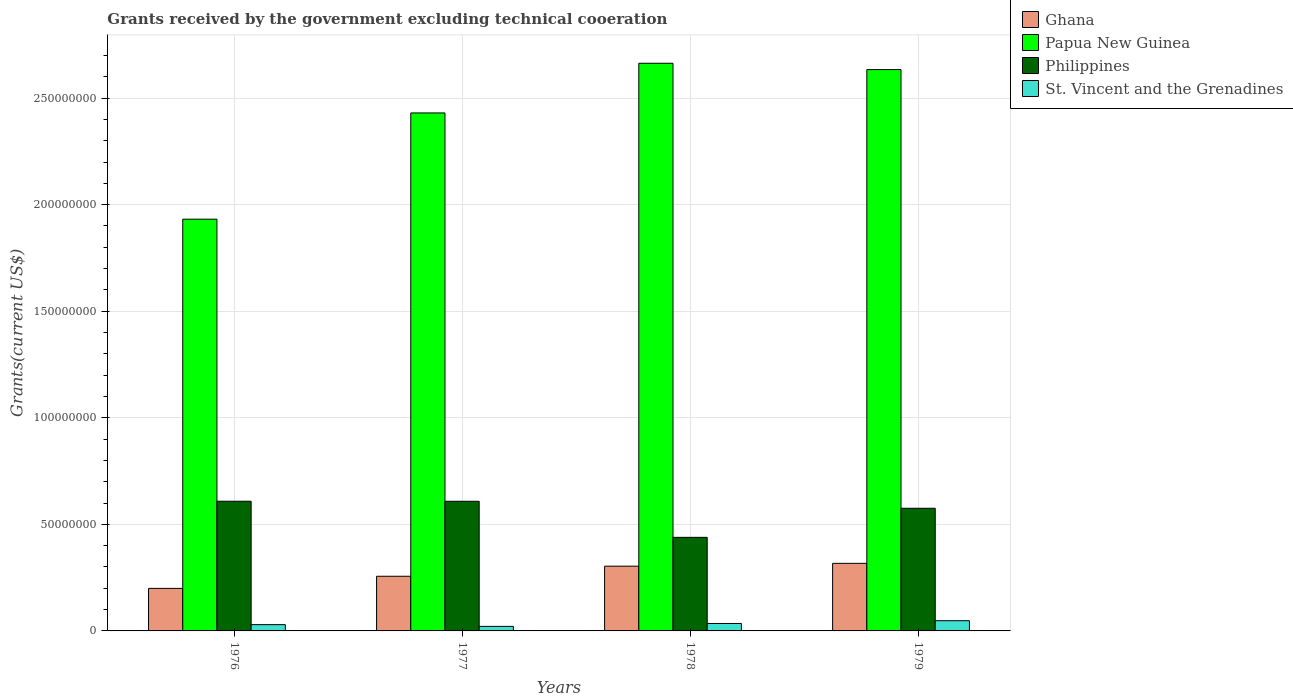Are the number of bars on each tick of the X-axis equal?
Your response must be concise. Yes. How many bars are there on the 4th tick from the right?
Offer a very short reply. 4. In how many cases, is the number of bars for a given year not equal to the number of legend labels?
Provide a short and direct response. 0. What is the total grants received by the government in Philippines in 1977?
Offer a very short reply. 6.08e+07. Across all years, what is the maximum total grants received by the government in Philippines?
Provide a short and direct response. 6.08e+07. Across all years, what is the minimum total grants received by the government in St. Vincent and the Grenadines?
Keep it short and to the point. 2.13e+06. In which year was the total grants received by the government in Papua New Guinea maximum?
Your response must be concise. 1978. In which year was the total grants received by the government in Papua New Guinea minimum?
Make the answer very short. 1976. What is the total total grants received by the government in Philippines in the graph?
Your answer should be compact. 2.23e+08. What is the difference between the total grants received by the government in Philippines in 1977 and that in 1979?
Your response must be concise. 3.29e+06. What is the difference between the total grants received by the government in Papua New Guinea in 1976 and the total grants received by the government in Ghana in 1978?
Offer a terse response. 1.63e+08. What is the average total grants received by the government in Philippines per year?
Ensure brevity in your answer.  5.58e+07. In the year 1976, what is the difference between the total grants received by the government in Papua New Guinea and total grants received by the government in Philippines?
Give a very brief answer. 1.32e+08. What is the ratio of the total grants received by the government in Ghana in 1977 to that in 1978?
Your answer should be very brief. 0.84. Is the total grants received by the government in Philippines in 1978 less than that in 1979?
Your response must be concise. Yes. Is the difference between the total grants received by the government in Papua New Guinea in 1976 and 1977 greater than the difference between the total grants received by the government in Philippines in 1976 and 1977?
Offer a terse response. No. What is the difference between the highest and the second highest total grants received by the government in St. Vincent and the Grenadines?
Ensure brevity in your answer.  1.30e+06. What is the difference between the highest and the lowest total grants received by the government in Papua New Guinea?
Your answer should be very brief. 7.32e+07. In how many years, is the total grants received by the government in Papua New Guinea greater than the average total grants received by the government in Papua New Guinea taken over all years?
Keep it short and to the point. 3. Is the sum of the total grants received by the government in St. Vincent and the Grenadines in 1977 and 1979 greater than the maximum total grants received by the government in Papua New Guinea across all years?
Provide a short and direct response. No. Is it the case that in every year, the sum of the total grants received by the government in Philippines and total grants received by the government in St. Vincent and the Grenadines is greater than the sum of total grants received by the government in Ghana and total grants received by the government in Papua New Guinea?
Your answer should be compact. No. What does the 2nd bar from the left in 1978 represents?
Your response must be concise. Papua New Guinea. What does the 2nd bar from the right in 1978 represents?
Offer a very short reply. Philippines. How many bars are there?
Offer a terse response. 16. How many years are there in the graph?
Make the answer very short. 4. Does the graph contain any zero values?
Your answer should be compact. No. Does the graph contain grids?
Provide a short and direct response. Yes. Where does the legend appear in the graph?
Ensure brevity in your answer.  Top right. How many legend labels are there?
Offer a terse response. 4. What is the title of the graph?
Offer a very short reply. Grants received by the government excluding technical cooeration. Does "Ghana" appear as one of the legend labels in the graph?
Offer a terse response. Yes. What is the label or title of the Y-axis?
Provide a succinct answer. Grants(current US$). What is the Grants(current US$) of Ghana in 1976?
Provide a succinct answer. 2.00e+07. What is the Grants(current US$) in Papua New Guinea in 1976?
Offer a terse response. 1.93e+08. What is the Grants(current US$) in Philippines in 1976?
Keep it short and to the point. 6.08e+07. What is the Grants(current US$) of St. Vincent and the Grenadines in 1976?
Ensure brevity in your answer.  2.94e+06. What is the Grants(current US$) in Ghana in 1977?
Provide a succinct answer. 2.56e+07. What is the Grants(current US$) of Papua New Guinea in 1977?
Provide a short and direct response. 2.43e+08. What is the Grants(current US$) of Philippines in 1977?
Make the answer very short. 6.08e+07. What is the Grants(current US$) of St. Vincent and the Grenadines in 1977?
Provide a short and direct response. 2.13e+06. What is the Grants(current US$) of Ghana in 1978?
Provide a short and direct response. 3.04e+07. What is the Grants(current US$) of Papua New Guinea in 1978?
Your response must be concise. 2.66e+08. What is the Grants(current US$) of Philippines in 1978?
Provide a succinct answer. 4.39e+07. What is the Grants(current US$) in St. Vincent and the Grenadines in 1978?
Make the answer very short. 3.49e+06. What is the Grants(current US$) of Ghana in 1979?
Your answer should be compact. 3.17e+07. What is the Grants(current US$) in Papua New Guinea in 1979?
Your response must be concise. 2.63e+08. What is the Grants(current US$) of Philippines in 1979?
Your response must be concise. 5.75e+07. What is the Grants(current US$) of St. Vincent and the Grenadines in 1979?
Ensure brevity in your answer.  4.79e+06. Across all years, what is the maximum Grants(current US$) in Ghana?
Give a very brief answer. 3.17e+07. Across all years, what is the maximum Grants(current US$) in Papua New Guinea?
Provide a short and direct response. 2.66e+08. Across all years, what is the maximum Grants(current US$) of Philippines?
Make the answer very short. 6.08e+07. Across all years, what is the maximum Grants(current US$) in St. Vincent and the Grenadines?
Provide a succinct answer. 4.79e+06. Across all years, what is the minimum Grants(current US$) of Ghana?
Offer a terse response. 2.00e+07. Across all years, what is the minimum Grants(current US$) of Papua New Guinea?
Make the answer very short. 1.93e+08. Across all years, what is the minimum Grants(current US$) in Philippines?
Your answer should be very brief. 4.39e+07. Across all years, what is the minimum Grants(current US$) of St. Vincent and the Grenadines?
Keep it short and to the point. 2.13e+06. What is the total Grants(current US$) of Ghana in the graph?
Your answer should be very brief. 1.08e+08. What is the total Grants(current US$) in Papua New Guinea in the graph?
Your response must be concise. 9.66e+08. What is the total Grants(current US$) in Philippines in the graph?
Ensure brevity in your answer.  2.23e+08. What is the total Grants(current US$) in St. Vincent and the Grenadines in the graph?
Your answer should be compact. 1.34e+07. What is the difference between the Grants(current US$) in Ghana in 1976 and that in 1977?
Make the answer very short. -5.69e+06. What is the difference between the Grants(current US$) of Papua New Guinea in 1976 and that in 1977?
Provide a succinct answer. -4.98e+07. What is the difference between the Grants(current US$) of Philippines in 1976 and that in 1977?
Your response must be concise. 10000. What is the difference between the Grants(current US$) in St. Vincent and the Grenadines in 1976 and that in 1977?
Keep it short and to the point. 8.10e+05. What is the difference between the Grants(current US$) of Ghana in 1976 and that in 1978?
Make the answer very short. -1.04e+07. What is the difference between the Grants(current US$) of Papua New Guinea in 1976 and that in 1978?
Offer a terse response. -7.32e+07. What is the difference between the Grants(current US$) in Philippines in 1976 and that in 1978?
Provide a succinct answer. 1.69e+07. What is the difference between the Grants(current US$) of St. Vincent and the Grenadines in 1976 and that in 1978?
Make the answer very short. -5.50e+05. What is the difference between the Grants(current US$) of Ghana in 1976 and that in 1979?
Make the answer very short. -1.17e+07. What is the difference between the Grants(current US$) in Papua New Guinea in 1976 and that in 1979?
Make the answer very short. -7.02e+07. What is the difference between the Grants(current US$) in Philippines in 1976 and that in 1979?
Your answer should be very brief. 3.30e+06. What is the difference between the Grants(current US$) in St. Vincent and the Grenadines in 1976 and that in 1979?
Give a very brief answer. -1.85e+06. What is the difference between the Grants(current US$) of Ghana in 1977 and that in 1978?
Your answer should be compact. -4.73e+06. What is the difference between the Grants(current US$) in Papua New Guinea in 1977 and that in 1978?
Provide a short and direct response. -2.33e+07. What is the difference between the Grants(current US$) in Philippines in 1977 and that in 1978?
Offer a terse response. 1.69e+07. What is the difference between the Grants(current US$) of St. Vincent and the Grenadines in 1977 and that in 1978?
Offer a terse response. -1.36e+06. What is the difference between the Grants(current US$) of Ghana in 1977 and that in 1979?
Give a very brief answer. -6.05e+06. What is the difference between the Grants(current US$) of Papua New Guinea in 1977 and that in 1979?
Offer a terse response. -2.04e+07. What is the difference between the Grants(current US$) in Philippines in 1977 and that in 1979?
Your answer should be very brief. 3.29e+06. What is the difference between the Grants(current US$) of St. Vincent and the Grenadines in 1977 and that in 1979?
Ensure brevity in your answer.  -2.66e+06. What is the difference between the Grants(current US$) of Ghana in 1978 and that in 1979?
Your answer should be very brief. -1.32e+06. What is the difference between the Grants(current US$) in Papua New Guinea in 1978 and that in 1979?
Your answer should be compact. 2.96e+06. What is the difference between the Grants(current US$) in Philippines in 1978 and that in 1979?
Provide a short and direct response. -1.36e+07. What is the difference between the Grants(current US$) of St. Vincent and the Grenadines in 1978 and that in 1979?
Ensure brevity in your answer.  -1.30e+06. What is the difference between the Grants(current US$) of Ghana in 1976 and the Grants(current US$) of Papua New Guinea in 1977?
Keep it short and to the point. -2.23e+08. What is the difference between the Grants(current US$) of Ghana in 1976 and the Grants(current US$) of Philippines in 1977?
Your response must be concise. -4.09e+07. What is the difference between the Grants(current US$) in Ghana in 1976 and the Grants(current US$) in St. Vincent and the Grenadines in 1977?
Keep it short and to the point. 1.78e+07. What is the difference between the Grants(current US$) in Papua New Guinea in 1976 and the Grants(current US$) in Philippines in 1977?
Make the answer very short. 1.32e+08. What is the difference between the Grants(current US$) in Papua New Guinea in 1976 and the Grants(current US$) in St. Vincent and the Grenadines in 1977?
Make the answer very short. 1.91e+08. What is the difference between the Grants(current US$) in Philippines in 1976 and the Grants(current US$) in St. Vincent and the Grenadines in 1977?
Provide a succinct answer. 5.87e+07. What is the difference between the Grants(current US$) of Ghana in 1976 and the Grants(current US$) of Papua New Guinea in 1978?
Give a very brief answer. -2.46e+08. What is the difference between the Grants(current US$) in Ghana in 1976 and the Grants(current US$) in Philippines in 1978?
Your answer should be compact. -2.39e+07. What is the difference between the Grants(current US$) in Ghana in 1976 and the Grants(current US$) in St. Vincent and the Grenadines in 1978?
Give a very brief answer. 1.65e+07. What is the difference between the Grants(current US$) in Papua New Guinea in 1976 and the Grants(current US$) in Philippines in 1978?
Offer a terse response. 1.49e+08. What is the difference between the Grants(current US$) in Papua New Guinea in 1976 and the Grants(current US$) in St. Vincent and the Grenadines in 1978?
Ensure brevity in your answer.  1.90e+08. What is the difference between the Grants(current US$) of Philippines in 1976 and the Grants(current US$) of St. Vincent and the Grenadines in 1978?
Provide a short and direct response. 5.74e+07. What is the difference between the Grants(current US$) in Ghana in 1976 and the Grants(current US$) in Papua New Guinea in 1979?
Give a very brief answer. -2.43e+08. What is the difference between the Grants(current US$) in Ghana in 1976 and the Grants(current US$) in Philippines in 1979?
Ensure brevity in your answer.  -3.76e+07. What is the difference between the Grants(current US$) in Ghana in 1976 and the Grants(current US$) in St. Vincent and the Grenadines in 1979?
Your response must be concise. 1.52e+07. What is the difference between the Grants(current US$) in Papua New Guinea in 1976 and the Grants(current US$) in Philippines in 1979?
Provide a succinct answer. 1.36e+08. What is the difference between the Grants(current US$) in Papua New Guinea in 1976 and the Grants(current US$) in St. Vincent and the Grenadines in 1979?
Your response must be concise. 1.88e+08. What is the difference between the Grants(current US$) of Philippines in 1976 and the Grants(current US$) of St. Vincent and the Grenadines in 1979?
Offer a very short reply. 5.60e+07. What is the difference between the Grants(current US$) in Ghana in 1977 and the Grants(current US$) in Papua New Guinea in 1978?
Give a very brief answer. -2.41e+08. What is the difference between the Grants(current US$) in Ghana in 1977 and the Grants(current US$) in Philippines in 1978?
Your answer should be compact. -1.82e+07. What is the difference between the Grants(current US$) in Ghana in 1977 and the Grants(current US$) in St. Vincent and the Grenadines in 1978?
Your answer should be compact. 2.22e+07. What is the difference between the Grants(current US$) in Papua New Guinea in 1977 and the Grants(current US$) in Philippines in 1978?
Your answer should be very brief. 1.99e+08. What is the difference between the Grants(current US$) of Papua New Guinea in 1977 and the Grants(current US$) of St. Vincent and the Grenadines in 1978?
Give a very brief answer. 2.40e+08. What is the difference between the Grants(current US$) of Philippines in 1977 and the Grants(current US$) of St. Vincent and the Grenadines in 1978?
Your answer should be very brief. 5.73e+07. What is the difference between the Grants(current US$) of Ghana in 1977 and the Grants(current US$) of Papua New Guinea in 1979?
Keep it short and to the point. -2.38e+08. What is the difference between the Grants(current US$) of Ghana in 1977 and the Grants(current US$) of Philippines in 1979?
Provide a short and direct response. -3.19e+07. What is the difference between the Grants(current US$) of Ghana in 1977 and the Grants(current US$) of St. Vincent and the Grenadines in 1979?
Offer a terse response. 2.09e+07. What is the difference between the Grants(current US$) in Papua New Guinea in 1977 and the Grants(current US$) in Philippines in 1979?
Offer a terse response. 1.85e+08. What is the difference between the Grants(current US$) in Papua New Guinea in 1977 and the Grants(current US$) in St. Vincent and the Grenadines in 1979?
Offer a very short reply. 2.38e+08. What is the difference between the Grants(current US$) in Philippines in 1977 and the Grants(current US$) in St. Vincent and the Grenadines in 1979?
Offer a very short reply. 5.60e+07. What is the difference between the Grants(current US$) in Ghana in 1978 and the Grants(current US$) in Papua New Guinea in 1979?
Keep it short and to the point. -2.33e+08. What is the difference between the Grants(current US$) in Ghana in 1978 and the Grants(current US$) in Philippines in 1979?
Provide a short and direct response. -2.72e+07. What is the difference between the Grants(current US$) in Ghana in 1978 and the Grants(current US$) in St. Vincent and the Grenadines in 1979?
Make the answer very short. 2.56e+07. What is the difference between the Grants(current US$) in Papua New Guinea in 1978 and the Grants(current US$) in Philippines in 1979?
Make the answer very short. 2.09e+08. What is the difference between the Grants(current US$) of Papua New Guinea in 1978 and the Grants(current US$) of St. Vincent and the Grenadines in 1979?
Make the answer very short. 2.62e+08. What is the difference between the Grants(current US$) of Philippines in 1978 and the Grants(current US$) of St. Vincent and the Grenadines in 1979?
Offer a terse response. 3.91e+07. What is the average Grants(current US$) in Ghana per year?
Your answer should be very brief. 2.69e+07. What is the average Grants(current US$) of Papua New Guinea per year?
Your response must be concise. 2.41e+08. What is the average Grants(current US$) of Philippines per year?
Provide a succinct answer. 5.58e+07. What is the average Grants(current US$) of St. Vincent and the Grenadines per year?
Your answer should be compact. 3.34e+06. In the year 1976, what is the difference between the Grants(current US$) in Ghana and Grants(current US$) in Papua New Guinea?
Offer a terse response. -1.73e+08. In the year 1976, what is the difference between the Grants(current US$) of Ghana and Grants(current US$) of Philippines?
Keep it short and to the point. -4.09e+07. In the year 1976, what is the difference between the Grants(current US$) of Ghana and Grants(current US$) of St. Vincent and the Grenadines?
Your answer should be compact. 1.70e+07. In the year 1976, what is the difference between the Grants(current US$) of Papua New Guinea and Grants(current US$) of Philippines?
Your answer should be very brief. 1.32e+08. In the year 1976, what is the difference between the Grants(current US$) of Papua New Guinea and Grants(current US$) of St. Vincent and the Grenadines?
Make the answer very short. 1.90e+08. In the year 1976, what is the difference between the Grants(current US$) of Philippines and Grants(current US$) of St. Vincent and the Grenadines?
Keep it short and to the point. 5.79e+07. In the year 1977, what is the difference between the Grants(current US$) in Ghana and Grants(current US$) in Papua New Guinea?
Offer a terse response. -2.17e+08. In the year 1977, what is the difference between the Grants(current US$) of Ghana and Grants(current US$) of Philippines?
Your answer should be very brief. -3.52e+07. In the year 1977, what is the difference between the Grants(current US$) in Ghana and Grants(current US$) in St. Vincent and the Grenadines?
Give a very brief answer. 2.35e+07. In the year 1977, what is the difference between the Grants(current US$) of Papua New Guinea and Grants(current US$) of Philippines?
Your answer should be very brief. 1.82e+08. In the year 1977, what is the difference between the Grants(current US$) of Papua New Guinea and Grants(current US$) of St. Vincent and the Grenadines?
Your answer should be very brief. 2.41e+08. In the year 1977, what is the difference between the Grants(current US$) in Philippines and Grants(current US$) in St. Vincent and the Grenadines?
Give a very brief answer. 5.87e+07. In the year 1978, what is the difference between the Grants(current US$) in Ghana and Grants(current US$) in Papua New Guinea?
Make the answer very short. -2.36e+08. In the year 1978, what is the difference between the Grants(current US$) of Ghana and Grants(current US$) of Philippines?
Give a very brief answer. -1.35e+07. In the year 1978, what is the difference between the Grants(current US$) in Ghana and Grants(current US$) in St. Vincent and the Grenadines?
Your response must be concise. 2.69e+07. In the year 1978, what is the difference between the Grants(current US$) of Papua New Guinea and Grants(current US$) of Philippines?
Offer a terse response. 2.22e+08. In the year 1978, what is the difference between the Grants(current US$) in Papua New Guinea and Grants(current US$) in St. Vincent and the Grenadines?
Provide a short and direct response. 2.63e+08. In the year 1978, what is the difference between the Grants(current US$) of Philippines and Grants(current US$) of St. Vincent and the Grenadines?
Ensure brevity in your answer.  4.04e+07. In the year 1979, what is the difference between the Grants(current US$) in Ghana and Grants(current US$) in Papua New Guinea?
Keep it short and to the point. -2.32e+08. In the year 1979, what is the difference between the Grants(current US$) of Ghana and Grants(current US$) of Philippines?
Ensure brevity in your answer.  -2.58e+07. In the year 1979, what is the difference between the Grants(current US$) in Ghana and Grants(current US$) in St. Vincent and the Grenadines?
Your answer should be compact. 2.69e+07. In the year 1979, what is the difference between the Grants(current US$) of Papua New Guinea and Grants(current US$) of Philippines?
Make the answer very short. 2.06e+08. In the year 1979, what is the difference between the Grants(current US$) of Papua New Guinea and Grants(current US$) of St. Vincent and the Grenadines?
Offer a terse response. 2.59e+08. In the year 1979, what is the difference between the Grants(current US$) of Philippines and Grants(current US$) of St. Vincent and the Grenadines?
Your answer should be very brief. 5.28e+07. What is the ratio of the Grants(current US$) of Ghana in 1976 to that in 1977?
Ensure brevity in your answer.  0.78. What is the ratio of the Grants(current US$) in Papua New Guinea in 1976 to that in 1977?
Offer a terse response. 0.79. What is the ratio of the Grants(current US$) in St. Vincent and the Grenadines in 1976 to that in 1977?
Give a very brief answer. 1.38. What is the ratio of the Grants(current US$) of Ghana in 1976 to that in 1978?
Your answer should be compact. 0.66. What is the ratio of the Grants(current US$) of Papua New Guinea in 1976 to that in 1978?
Your answer should be very brief. 0.73. What is the ratio of the Grants(current US$) of Philippines in 1976 to that in 1978?
Make the answer very short. 1.39. What is the ratio of the Grants(current US$) in St. Vincent and the Grenadines in 1976 to that in 1978?
Give a very brief answer. 0.84. What is the ratio of the Grants(current US$) of Ghana in 1976 to that in 1979?
Your answer should be compact. 0.63. What is the ratio of the Grants(current US$) of Papua New Guinea in 1976 to that in 1979?
Provide a succinct answer. 0.73. What is the ratio of the Grants(current US$) in Philippines in 1976 to that in 1979?
Provide a short and direct response. 1.06. What is the ratio of the Grants(current US$) of St. Vincent and the Grenadines in 1976 to that in 1979?
Your answer should be compact. 0.61. What is the ratio of the Grants(current US$) in Ghana in 1977 to that in 1978?
Keep it short and to the point. 0.84. What is the ratio of the Grants(current US$) of Papua New Guinea in 1977 to that in 1978?
Ensure brevity in your answer.  0.91. What is the ratio of the Grants(current US$) of Philippines in 1977 to that in 1978?
Offer a very short reply. 1.39. What is the ratio of the Grants(current US$) of St. Vincent and the Grenadines in 1977 to that in 1978?
Give a very brief answer. 0.61. What is the ratio of the Grants(current US$) of Ghana in 1977 to that in 1979?
Provide a succinct answer. 0.81. What is the ratio of the Grants(current US$) in Papua New Guinea in 1977 to that in 1979?
Your answer should be compact. 0.92. What is the ratio of the Grants(current US$) of Philippines in 1977 to that in 1979?
Provide a short and direct response. 1.06. What is the ratio of the Grants(current US$) of St. Vincent and the Grenadines in 1977 to that in 1979?
Make the answer very short. 0.44. What is the ratio of the Grants(current US$) of Ghana in 1978 to that in 1979?
Give a very brief answer. 0.96. What is the ratio of the Grants(current US$) of Papua New Guinea in 1978 to that in 1979?
Keep it short and to the point. 1.01. What is the ratio of the Grants(current US$) in Philippines in 1978 to that in 1979?
Your answer should be compact. 0.76. What is the ratio of the Grants(current US$) of St. Vincent and the Grenadines in 1978 to that in 1979?
Keep it short and to the point. 0.73. What is the difference between the highest and the second highest Grants(current US$) in Ghana?
Your answer should be compact. 1.32e+06. What is the difference between the highest and the second highest Grants(current US$) of Papua New Guinea?
Ensure brevity in your answer.  2.96e+06. What is the difference between the highest and the second highest Grants(current US$) in St. Vincent and the Grenadines?
Provide a short and direct response. 1.30e+06. What is the difference between the highest and the lowest Grants(current US$) in Ghana?
Your answer should be very brief. 1.17e+07. What is the difference between the highest and the lowest Grants(current US$) in Papua New Guinea?
Keep it short and to the point. 7.32e+07. What is the difference between the highest and the lowest Grants(current US$) of Philippines?
Your answer should be compact. 1.69e+07. What is the difference between the highest and the lowest Grants(current US$) of St. Vincent and the Grenadines?
Keep it short and to the point. 2.66e+06. 